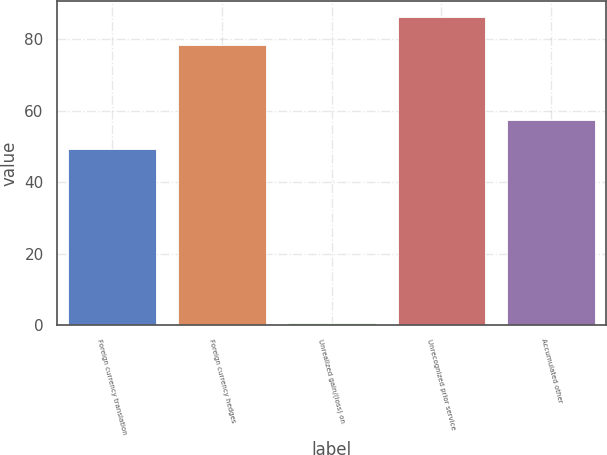<chart> <loc_0><loc_0><loc_500><loc_500><bar_chart><fcel>Foreign currency translation<fcel>Foreign currency hedges<fcel>Unrealized gain/(loss) on<fcel>Unrecognized prior service<fcel>Accumulated other<nl><fcel>49.4<fcel>78.4<fcel>0.6<fcel>86.33<fcel>57.33<nl></chart> 